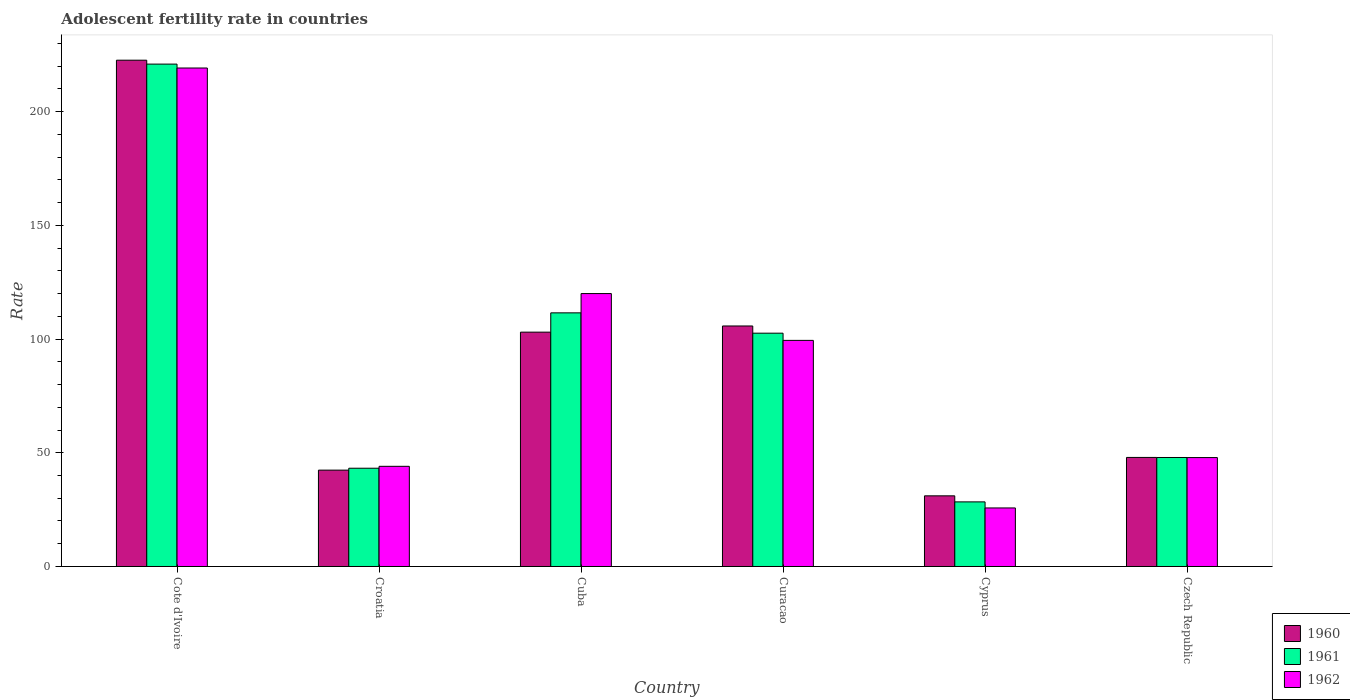How many different coloured bars are there?
Give a very brief answer. 3. How many groups of bars are there?
Give a very brief answer. 6. Are the number of bars per tick equal to the number of legend labels?
Your response must be concise. Yes. Are the number of bars on each tick of the X-axis equal?
Offer a terse response. Yes. How many bars are there on the 6th tick from the left?
Offer a terse response. 3. What is the label of the 2nd group of bars from the left?
Provide a short and direct response. Croatia. What is the adolescent fertility rate in 1962 in Cuba?
Your answer should be very brief. 120. Across all countries, what is the maximum adolescent fertility rate in 1961?
Your response must be concise. 220.9. Across all countries, what is the minimum adolescent fertility rate in 1960?
Your response must be concise. 31.07. In which country was the adolescent fertility rate in 1961 maximum?
Your response must be concise. Cote d'Ivoire. In which country was the adolescent fertility rate in 1962 minimum?
Your response must be concise. Cyprus. What is the total adolescent fertility rate in 1961 in the graph?
Make the answer very short. 554.54. What is the difference between the adolescent fertility rate in 1961 in Croatia and that in Cuba?
Your answer should be very brief. -68.31. What is the difference between the adolescent fertility rate in 1962 in Croatia and the adolescent fertility rate in 1960 in Cuba?
Your answer should be compact. -58.99. What is the average adolescent fertility rate in 1960 per country?
Make the answer very short. 92.13. What is the difference between the adolescent fertility rate of/in 1961 and adolescent fertility rate of/in 1962 in Cote d'Ivoire?
Your answer should be very brief. 1.72. What is the ratio of the adolescent fertility rate in 1962 in Cuba to that in Cyprus?
Keep it short and to the point. 4.66. Is the adolescent fertility rate in 1961 in Croatia less than that in Cuba?
Provide a succinct answer. Yes. What is the difference between the highest and the second highest adolescent fertility rate in 1960?
Give a very brief answer. -116.86. What is the difference between the highest and the lowest adolescent fertility rate in 1960?
Your response must be concise. 191.55. Is the sum of the adolescent fertility rate in 1961 in Croatia and Cyprus greater than the maximum adolescent fertility rate in 1960 across all countries?
Offer a terse response. No. What does the 1st bar from the right in Cote d'Ivoire represents?
Your answer should be compact. 1962. Are all the bars in the graph horizontal?
Keep it short and to the point. No. How many countries are there in the graph?
Your response must be concise. 6. Are the values on the major ticks of Y-axis written in scientific E-notation?
Give a very brief answer. No. Does the graph contain any zero values?
Provide a short and direct response. No. What is the title of the graph?
Make the answer very short. Adolescent fertility rate in countries. Does "1987" appear as one of the legend labels in the graph?
Offer a very short reply. No. What is the label or title of the Y-axis?
Give a very brief answer. Rate. What is the Rate of 1960 in Cote d'Ivoire?
Your answer should be compact. 222.62. What is the Rate in 1961 in Cote d'Ivoire?
Keep it short and to the point. 220.9. What is the Rate of 1962 in Cote d'Ivoire?
Provide a short and direct response. 219.18. What is the Rate of 1960 in Croatia?
Your answer should be compact. 42.37. What is the Rate in 1961 in Croatia?
Give a very brief answer. 43.21. What is the Rate of 1962 in Croatia?
Offer a very short reply. 44.05. What is the Rate in 1960 in Cuba?
Your answer should be very brief. 103.04. What is the Rate in 1961 in Cuba?
Provide a succinct answer. 111.52. What is the Rate of 1962 in Cuba?
Offer a terse response. 120. What is the Rate of 1960 in Curacao?
Ensure brevity in your answer.  105.75. What is the Rate of 1961 in Curacao?
Provide a short and direct response. 102.59. What is the Rate in 1962 in Curacao?
Ensure brevity in your answer.  99.42. What is the Rate in 1960 in Cyprus?
Make the answer very short. 31.07. What is the Rate in 1961 in Cyprus?
Give a very brief answer. 28.4. What is the Rate in 1962 in Cyprus?
Keep it short and to the point. 25.74. What is the Rate in 1960 in Czech Republic?
Provide a succinct answer. 47.95. What is the Rate of 1961 in Czech Republic?
Offer a very short reply. 47.92. What is the Rate of 1962 in Czech Republic?
Keep it short and to the point. 47.89. Across all countries, what is the maximum Rate in 1960?
Offer a very short reply. 222.62. Across all countries, what is the maximum Rate in 1961?
Your response must be concise. 220.9. Across all countries, what is the maximum Rate in 1962?
Give a very brief answer. 219.18. Across all countries, what is the minimum Rate of 1960?
Your response must be concise. 31.07. Across all countries, what is the minimum Rate of 1961?
Provide a succinct answer. 28.4. Across all countries, what is the minimum Rate of 1962?
Provide a short and direct response. 25.74. What is the total Rate of 1960 in the graph?
Make the answer very short. 552.8. What is the total Rate in 1961 in the graph?
Offer a very short reply. 554.54. What is the total Rate of 1962 in the graph?
Ensure brevity in your answer.  556.28. What is the difference between the Rate in 1960 in Cote d'Ivoire and that in Croatia?
Provide a succinct answer. 180.25. What is the difference between the Rate of 1961 in Cote d'Ivoire and that in Croatia?
Give a very brief answer. 177.69. What is the difference between the Rate in 1962 in Cote d'Ivoire and that in Croatia?
Your answer should be very brief. 175.14. What is the difference between the Rate of 1960 in Cote d'Ivoire and that in Cuba?
Provide a short and direct response. 119.58. What is the difference between the Rate of 1961 in Cote d'Ivoire and that in Cuba?
Your answer should be compact. 109.38. What is the difference between the Rate in 1962 in Cote d'Ivoire and that in Cuba?
Your response must be concise. 99.18. What is the difference between the Rate of 1960 in Cote d'Ivoire and that in Curacao?
Keep it short and to the point. 116.86. What is the difference between the Rate of 1961 in Cote d'Ivoire and that in Curacao?
Offer a terse response. 118.31. What is the difference between the Rate of 1962 in Cote d'Ivoire and that in Curacao?
Make the answer very short. 119.76. What is the difference between the Rate of 1960 in Cote d'Ivoire and that in Cyprus?
Your answer should be very brief. 191.55. What is the difference between the Rate of 1961 in Cote d'Ivoire and that in Cyprus?
Give a very brief answer. 192.49. What is the difference between the Rate in 1962 in Cote d'Ivoire and that in Cyprus?
Your response must be concise. 193.44. What is the difference between the Rate in 1960 in Cote d'Ivoire and that in Czech Republic?
Ensure brevity in your answer.  174.66. What is the difference between the Rate in 1961 in Cote d'Ivoire and that in Czech Republic?
Your answer should be very brief. 172.98. What is the difference between the Rate in 1962 in Cote d'Ivoire and that in Czech Republic?
Your response must be concise. 171.29. What is the difference between the Rate in 1960 in Croatia and that in Cuba?
Your response must be concise. -60.67. What is the difference between the Rate of 1961 in Croatia and that in Cuba?
Your answer should be very brief. -68.31. What is the difference between the Rate of 1962 in Croatia and that in Cuba?
Give a very brief answer. -75.95. What is the difference between the Rate in 1960 in Croatia and that in Curacao?
Your response must be concise. -63.39. What is the difference between the Rate of 1961 in Croatia and that in Curacao?
Make the answer very short. -59.38. What is the difference between the Rate of 1962 in Croatia and that in Curacao?
Give a very brief answer. -55.37. What is the difference between the Rate in 1960 in Croatia and that in Cyprus?
Ensure brevity in your answer.  11.3. What is the difference between the Rate of 1961 in Croatia and that in Cyprus?
Keep it short and to the point. 14.8. What is the difference between the Rate of 1962 in Croatia and that in Cyprus?
Provide a short and direct response. 18.3. What is the difference between the Rate in 1960 in Croatia and that in Czech Republic?
Give a very brief answer. -5.59. What is the difference between the Rate in 1961 in Croatia and that in Czech Republic?
Provide a short and direct response. -4.72. What is the difference between the Rate in 1962 in Croatia and that in Czech Republic?
Provide a short and direct response. -3.85. What is the difference between the Rate of 1960 in Cuba and that in Curacao?
Offer a very short reply. -2.71. What is the difference between the Rate of 1961 in Cuba and that in Curacao?
Offer a terse response. 8.93. What is the difference between the Rate of 1962 in Cuba and that in Curacao?
Give a very brief answer. 20.58. What is the difference between the Rate of 1960 in Cuba and that in Cyprus?
Give a very brief answer. 71.97. What is the difference between the Rate in 1961 in Cuba and that in Cyprus?
Give a very brief answer. 83.11. What is the difference between the Rate in 1962 in Cuba and that in Cyprus?
Make the answer very short. 94.26. What is the difference between the Rate in 1960 in Cuba and that in Czech Republic?
Your response must be concise. 55.09. What is the difference between the Rate in 1961 in Cuba and that in Czech Republic?
Offer a very short reply. 63.6. What is the difference between the Rate in 1962 in Cuba and that in Czech Republic?
Your response must be concise. 72.11. What is the difference between the Rate of 1960 in Curacao and that in Cyprus?
Ensure brevity in your answer.  74.69. What is the difference between the Rate of 1961 in Curacao and that in Cyprus?
Offer a very short reply. 74.18. What is the difference between the Rate of 1962 in Curacao and that in Cyprus?
Keep it short and to the point. 73.67. What is the difference between the Rate in 1960 in Curacao and that in Czech Republic?
Your answer should be very brief. 57.8. What is the difference between the Rate of 1961 in Curacao and that in Czech Republic?
Offer a very short reply. 54.66. What is the difference between the Rate in 1962 in Curacao and that in Czech Republic?
Offer a terse response. 51.52. What is the difference between the Rate of 1960 in Cyprus and that in Czech Republic?
Your answer should be compact. -16.89. What is the difference between the Rate in 1961 in Cyprus and that in Czech Republic?
Your answer should be compact. -19.52. What is the difference between the Rate of 1962 in Cyprus and that in Czech Republic?
Provide a short and direct response. -22.15. What is the difference between the Rate of 1960 in Cote d'Ivoire and the Rate of 1961 in Croatia?
Your response must be concise. 179.41. What is the difference between the Rate in 1960 in Cote d'Ivoire and the Rate in 1962 in Croatia?
Your answer should be compact. 178.57. What is the difference between the Rate of 1961 in Cote d'Ivoire and the Rate of 1962 in Croatia?
Your answer should be very brief. 176.85. What is the difference between the Rate of 1960 in Cote d'Ivoire and the Rate of 1961 in Cuba?
Give a very brief answer. 111.1. What is the difference between the Rate of 1960 in Cote d'Ivoire and the Rate of 1962 in Cuba?
Offer a very short reply. 102.62. What is the difference between the Rate in 1961 in Cote d'Ivoire and the Rate in 1962 in Cuba?
Keep it short and to the point. 100.9. What is the difference between the Rate of 1960 in Cote d'Ivoire and the Rate of 1961 in Curacao?
Make the answer very short. 120.03. What is the difference between the Rate in 1960 in Cote d'Ivoire and the Rate in 1962 in Curacao?
Offer a very short reply. 123.2. What is the difference between the Rate of 1961 in Cote d'Ivoire and the Rate of 1962 in Curacao?
Provide a short and direct response. 121.48. What is the difference between the Rate in 1960 in Cote d'Ivoire and the Rate in 1961 in Cyprus?
Keep it short and to the point. 194.21. What is the difference between the Rate in 1960 in Cote d'Ivoire and the Rate in 1962 in Cyprus?
Provide a short and direct response. 196.87. What is the difference between the Rate of 1961 in Cote d'Ivoire and the Rate of 1962 in Cyprus?
Offer a terse response. 195.16. What is the difference between the Rate of 1960 in Cote d'Ivoire and the Rate of 1961 in Czech Republic?
Provide a short and direct response. 174.69. What is the difference between the Rate of 1960 in Cote d'Ivoire and the Rate of 1962 in Czech Republic?
Ensure brevity in your answer.  174.72. What is the difference between the Rate in 1961 in Cote d'Ivoire and the Rate in 1962 in Czech Republic?
Provide a succinct answer. 173.01. What is the difference between the Rate in 1960 in Croatia and the Rate in 1961 in Cuba?
Your response must be concise. -69.15. What is the difference between the Rate in 1960 in Croatia and the Rate in 1962 in Cuba?
Your answer should be very brief. -77.63. What is the difference between the Rate in 1961 in Croatia and the Rate in 1962 in Cuba?
Offer a very short reply. -76.79. What is the difference between the Rate of 1960 in Croatia and the Rate of 1961 in Curacao?
Your answer should be very brief. -60.22. What is the difference between the Rate in 1960 in Croatia and the Rate in 1962 in Curacao?
Ensure brevity in your answer.  -57.05. What is the difference between the Rate of 1961 in Croatia and the Rate of 1962 in Curacao?
Your answer should be very brief. -56.21. What is the difference between the Rate of 1960 in Croatia and the Rate of 1961 in Cyprus?
Make the answer very short. 13.96. What is the difference between the Rate of 1960 in Croatia and the Rate of 1962 in Cyprus?
Offer a very short reply. 16.62. What is the difference between the Rate of 1961 in Croatia and the Rate of 1962 in Cyprus?
Your answer should be very brief. 17.46. What is the difference between the Rate of 1960 in Croatia and the Rate of 1961 in Czech Republic?
Give a very brief answer. -5.56. What is the difference between the Rate in 1960 in Croatia and the Rate in 1962 in Czech Republic?
Your answer should be very brief. -5.52. What is the difference between the Rate in 1961 in Croatia and the Rate in 1962 in Czech Republic?
Make the answer very short. -4.69. What is the difference between the Rate in 1960 in Cuba and the Rate in 1961 in Curacao?
Your answer should be very brief. 0.45. What is the difference between the Rate of 1960 in Cuba and the Rate of 1962 in Curacao?
Keep it short and to the point. 3.62. What is the difference between the Rate of 1961 in Cuba and the Rate of 1962 in Curacao?
Your answer should be very brief. 12.1. What is the difference between the Rate of 1960 in Cuba and the Rate of 1961 in Cyprus?
Offer a terse response. 74.64. What is the difference between the Rate of 1960 in Cuba and the Rate of 1962 in Cyprus?
Make the answer very short. 77.3. What is the difference between the Rate in 1961 in Cuba and the Rate in 1962 in Cyprus?
Your response must be concise. 85.78. What is the difference between the Rate of 1960 in Cuba and the Rate of 1961 in Czech Republic?
Offer a very short reply. 55.12. What is the difference between the Rate in 1960 in Cuba and the Rate in 1962 in Czech Republic?
Keep it short and to the point. 55.15. What is the difference between the Rate in 1961 in Cuba and the Rate in 1962 in Czech Republic?
Provide a succinct answer. 63.63. What is the difference between the Rate of 1960 in Curacao and the Rate of 1961 in Cyprus?
Provide a succinct answer. 77.35. What is the difference between the Rate in 1960 in Curacao and the Rate in 1962 in Cyprus?
Make the answer very short. 80.01. What is the difference between the Rate in 1961 in Curacao and the Rate in 1962 in Cyprus?
Provide a succinct answer. 76.84. What is the difference between the Rate in 1960 in Curacao and the Rate in 1961 in Czech Republic?
Provide a short and direct response. 57.83. What is the difference between the Rate in 1960 in Curacao and the Rate in 1962 in Czech Republic?
Give a very brief answer. 57.86. What is the difference between the Rate in 1961 in Curacao and the Rate in 1962 in Czech Republic?
Keep it short and to the point. 54.69. What is the difference between the Rate of 1960 in Cyprus and the Rate of 1961 in Czech Republic?
Your answer should be very brief. -16.86. What is the difference between the Rate of 1960 in Cyprus and the Rate of 1962 in Czech Republic?
Provide a short and direct response. -16.83. What is the difference between the Rate in 1961 in Cyprus and the Rate in 1962 in Czech Republic?
Ensure brevity in your answer.  -19.49. What is the average Rate in 1960 per country?
Your answer should be very brief. 92.13. What is the average Rate in 1961 per country?
Make the answer very short. 92.42. What is the average Rate of 1962 per country?
Ensure brevity in your answer.  92.71. What is the difference between the Rate of 1960 and Rate of 1961 in Cote d'Ivoire?
Provide a short and direct response. 1.72. What is the difference between the Rate in 1960 and Rate in 1962 in Cote d'Ivoire?
Give a very brief answer. 3.44. What is the difference between the Rate of 1961 and Rate of 1962 in Cote d'Ivoire?
Your answer should be very brief. 1.72. What is the difference between the Rate in 1960 and Rate in 1961 in Croatia?
Provide a succinct answer. -0.84. What is the difference between the Rate in 1960 and Rate in 1962 in Croatia?
Your response must be concise. -1.68. What is the difference between the Rate in 1961 and Rate in 1962 in Croatia?
Keep it short and to the point. -0.84. What is the difference between the Rate of 1960 and Rate of 1961 in Cuba?
Offer a terse response. -8.48. What is the difference between the Rate in 1960 and Rate in 1962 in Cuba?
Offer a very short reply. -16.96. What is the difference between the Rate in 1961 and Rate in 1962 in Cuba?
Keep it short and to the point. -8.48. What is the difference between the Rate in 1960 and Rate in 1961 in Curacao?
Your answer should be very brief. 3.17. What is the difference between the Rate in 1960 and Rate in 1962 in Curacao?
Your response must be concise. 6.34. What is the difference between the Rate of 1961 and Rate of 1962 in Curacao?
Give a very brief answer. 3.17. What is the difference between the Rate in 1960 and Rate in 1961 in Cyprus?
Make the answer very short. 2.66. What is the difference between the Rate in 1960 and Rate in 1962 in Cyprus?
Your response must be concise. 5.32. What is the difference between the Rate in 1961 and Rate in 1962 in Cyprus?
Provide a succinct answer. 2.66. What is the difference between the Rate in 1960 and Rate in 1961 in Czech Republic?
Your answer should be very brief. 0.03. What is the difference between the Rate in 1960 and Rate in 1962 in Czech Republic?
Ensure brevity in your answer.  0.06. What is the difference between the Rate in 1961 and Rate in 1962 in Czech Republic?
Ensure brevity in your answer.  0.03. What is the ratio of the Rate of 1960 in Cote d'Ivoire to that in Croatia?
Give a very brief answer. 5.25. What is the ratio of the Rate in 1961 in Cote d'Ivoire to that in Croatia?
Your answer should be compact. 5.11. What is the ratio of the Rate in 1962 in Cote d'Ivoire to that in Croatia?
Give a very brief answer. 4.98. What is the ratio of the Rate of 1960 in Cote d'Ivoire to that in Cuba?
Your answer should be very brief. 2.16. What is the ratio of the Rate of 1961 in Cote d'Ivoire to that in Cuba?
Provide a succinct answer. 1.98. What is the ratio of the Rate of 1962 in Cote d'Ivoire to that in Cuba?
Keep it short and to the point. 1.83. What is the ratio of the Rate of 1960 in Cote d'Ivoire to that in Curacao?
Provide a succinct answer. 2.1. What is the ratio of the Rate in 1961 in Cote d'Ivoire to that in Curacao?
Your response must be concise. 2.15. What is the ratio of the Rate in 1962 in Cote d'Ivoire to that in Curacao?
Provide a succinct answer. 2.2. What is the ratio of the Rate of 1960 in Cote d'Ivoire to that in Cyprus?
Provide a succinct answer. 7.17. What is the ratio of the Rate in 1961 in Cote d'Ivoire to that in Cyprus?
Give a very brief answer. 7.78. What is the ratio of the Rate of 1962 in Cote d'Ivoire to that in Cyprus?
Give a very brief answer. 8.51. What is the ratio of the Rate of 1960 in Cote d'Ivoire to that in Czech Republic?
Make the answer very short. 4.64. What is the ratio of the Rate of 1961 in Cote d'Ivoire to that in Czech Republic?
Provide a short and direct response. 4.61. What is the ratio of the Rate in 1962 in Cote d'Ivoire to that in Czech Republic?
Your answer should be very brief. 4.58. What is the ratio of the Rate of 1960 in Croatia to that in Cuba?
Your response must be concise. 0.41. What is the ratio of the Rate of 1961 in Croatia to that in Cuba?
Offer a terse response. 0.39. What is the ratio of the Rate in 1962 in Croatia to that in Cuba?
Your answer should be very brief. 0.37. What is the ratio of the Rate in 1960 in Croatia to that in Curacao?
Give a very brief answer. 0.4. What is the ratio of the Rate of 1961 in Croatia to that in Curacao?
Give a very brief answer. 0.42. What is the ratio of the Rate in 1962 in Croatia to that in Curacao?
Give a very brief answer. 0.44. What is the ratio of the Rate in 1960 in Croatia to that in Cyprus?
Ensure brevity in your answer.  1.36. What is the ratio of the Rate in 1961 in Croatia to that in Cyprus?
Ensure brevity in your answer.  1.52. What is the ratio of the Rate of 1962 in Croatia to that in Cyprus?
Make the answer very short. 1.71. What is the ratio of the Rate of 1960 in Croatia to that in Czech Republic?
Your answer should be compact. 0.88. What is the ratio of the Rate in 1961 in Croatia to that in Czech Republic?
Your answer should be compact. 0.9. What is the ratio of the Rate in 1962 in Croatia to that in Czech Republic?
Your answer should be compact. 0.92. What is the ratio of the Rate in 1960 in Cuba to that in Curacao?
Provide a short and direct response. 0.97. What is the ratio of the Rate in 1961 in Cuba to that in Curacao?
Offer a very short reply. 1.09. What is the ratio of the Rate of 1962 in Cuba to that in Curacao?
Ensure brevity in your answer.  1.21. What is the ratio of the Rate of 1960 in Cuba to that in Cyprus?
Offer a terse response. 3.32. What is the ratio of the Rate of 1961 in Cuba to that in Cyprus?
Your response must be concise. 3.93. What is the ratio of the Rate of 1962 in Cuba to that in Cyprus?
Keep it short and to the point. 4.66. What is the ratio of the Rate in 1960 in Cuba to that in Czech Republic?
Provide a short and direct response. 2.15. What is the ratio of the Rate of 1961 in Cuba to that in Czech Republic?
Keep it short and to the point. 2.33. What is the ratio of the Rate of 1962 in Cuba to that in Czech Republic?
Provide a succinct answer. 2.51. What is the ratio of the Rate in 1960 in Curacao to that in Cyprus?
Make the answer very short. 3.4. What is the ratio of the Rate in 1961 in Curacao to that in Cyprus?
Provide a short and direct response. 3.61. What is the ratio of the Rate of 1962 in Curacao to that in Cyprus?
Give a very brief answer. 3.86. What is the ratio of the Rate of 1960 in Curacao to that in Czech Republic?
Make the answer very short. 2.21. What is the ratio of the Rate of 1961 in Curacao to that in Czech Republic?
Provide a succinct answer. 2.14. What is the ratio of the Rate in 1962 in Curacao to that in Czech Republic?
Keep it short and to the point. 2.08. What is the ratio of the Rate in 1960 in Cyprus to that in Czech Republic?
Your answer should be compact. 0.65. What is the ratio of the Rate in 1961 in Cyprus to that in Czech Republic?
Your answer should be very brief. 0.59. What is the ratio of the Rate in 1962 in Cyprus to that in Czech Republic?
Provide a succinct answer. 0.54. What is the difference between the highest and the second highest Rate in 1960?
Ensure brevity in your answer.  116.86. What is the difference between the highest and the second highest Rate of 1961?
Keep it short and to the point. 109.38. What is the difference between the highest and the second highest Rate of 1962?
Make the answer very short. 99.18. What is the difference between the highest and the lowest Rate in 1960?
Make the answer very short. 191.55. What is the difference between the highest and the lowest Rate of 1961?
Make the answer very short. 192.49. What is the difference between the highest and the lowest Rate of 1962?
Your answer should be very brief. 193.44. 